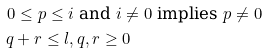<formula> <loc_0><loc_0><loc_500><loc_500>0 \leq p \leq i & \text { and $i \ne 0$ implies $p \ne 0$} \\ q + r \leq l , & \, q , r \geq 0</formula> 